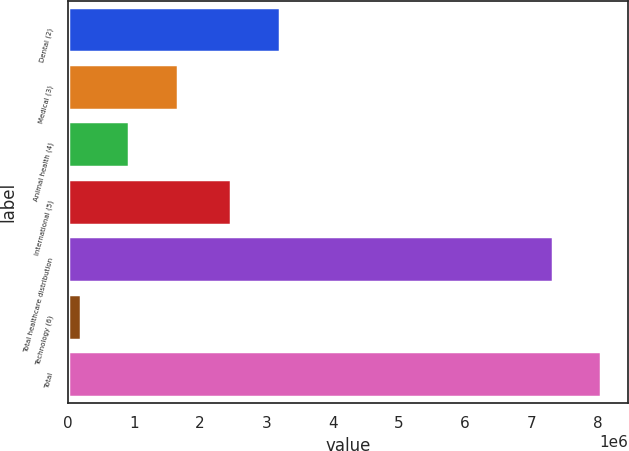Convert chart to OTSL. <chart><loc_0><loc_0><loc_500><loc_500><bar_chart><fcel>Dental (2)<fcel>Medical (3)<fcel>Animal health (4)<fcel>International (5)<fcel>Total healthcare distribution<fcel>Technology (6)<fcel>Total<nl><fcel>3.20096e+06<fcel>1.66532e+06<fcel>932636<fcel>2.46828e+06<fcel>7.32684e+06<fcel>199952<fcel>8.05952e+06<nl></chart> 